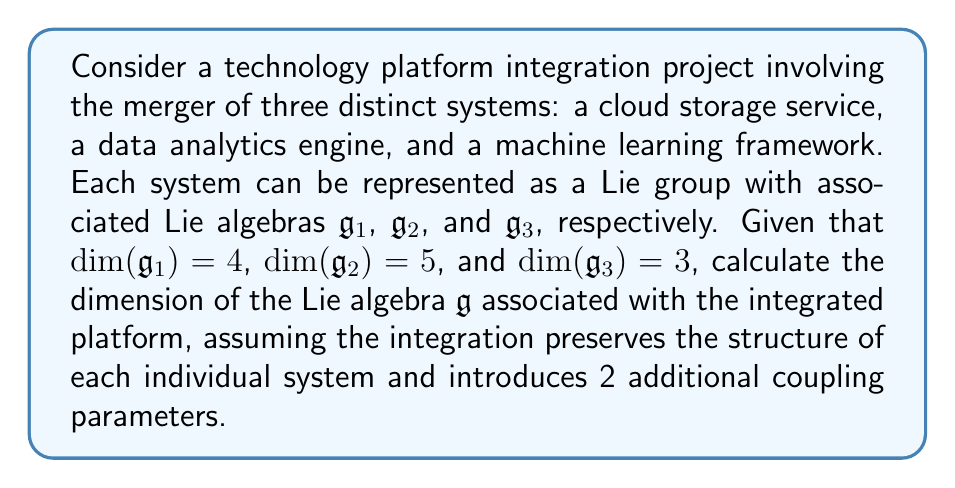What is the answer to this math problem? To solve this problem, we need to consider the following steps:

1) First, recall that the dimension of a Lie algebra is equal to the number of generators or basis elements of the algebra.

2) In this case, we have three separate Lie algebras:
   - $\mathfrak{g}_1$ with dimension 4
   - $\mathfrak{g}_2$ with dimension 5
   - $\mathfrak{g}_3$ with dimension 3

3) When integrating these systems, we are essentially creating a new Lie algebra that encompasses all three original algebras. In Lie theory, this is typically done through a direct sum operation.

4) The dimension of a direct sum of Lie algebras is the sum of the dimensions of the individual algebras. So, without considering the coupling parameters, we would have:

   $$\dim(\mathfrak{g}_1 \oplus \mathfrak{g}_2 \oplus \mathfrak{g}_3) = \dim(\mathfrak{g}_1) + \dim(\mathfrak{g}_2) + \dim(\mathfrak{g}_3) = 4 + 5 + 3 = 12$$

5) However, the question states that the integration introduces 2 additional coupling parameters. In Lie algebra terms, these coupling parameters can be thought of as additional generators that define how the three systems interact with each other.

6) Therefore, to get the final dimension of the integrated system's Lie algebra, we need to add these 2 additional dimensions to our previous sum:

   $$\dim(\mathfrak{g}) = \dim(\mathfrak{g}_1 \oplus \mathfrak{g}_2 \oplus \mathfrak{g}_3) + 2 = 12 + 2 = 14$$

Thus, the dimension of the Lie algebra associated with the integrated platform is 14.
Answer: The dimension of the Lie algebra $\mathfrak{g}$ associated with the integrated platform is 14. 